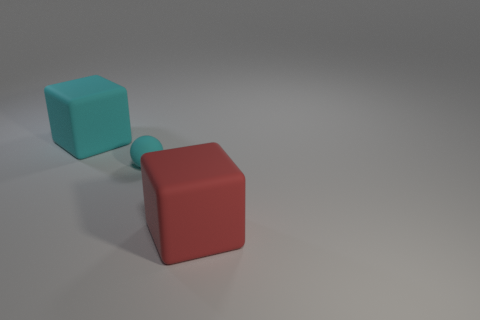What are the possible materials the two cubes could be made from, besides rubber? Aside from rubber, the cubes could theoretically be made from a variety of materials like plastic, wood, or even metal, depending on their intended use and the visual aesthetics one aims to achieve. 